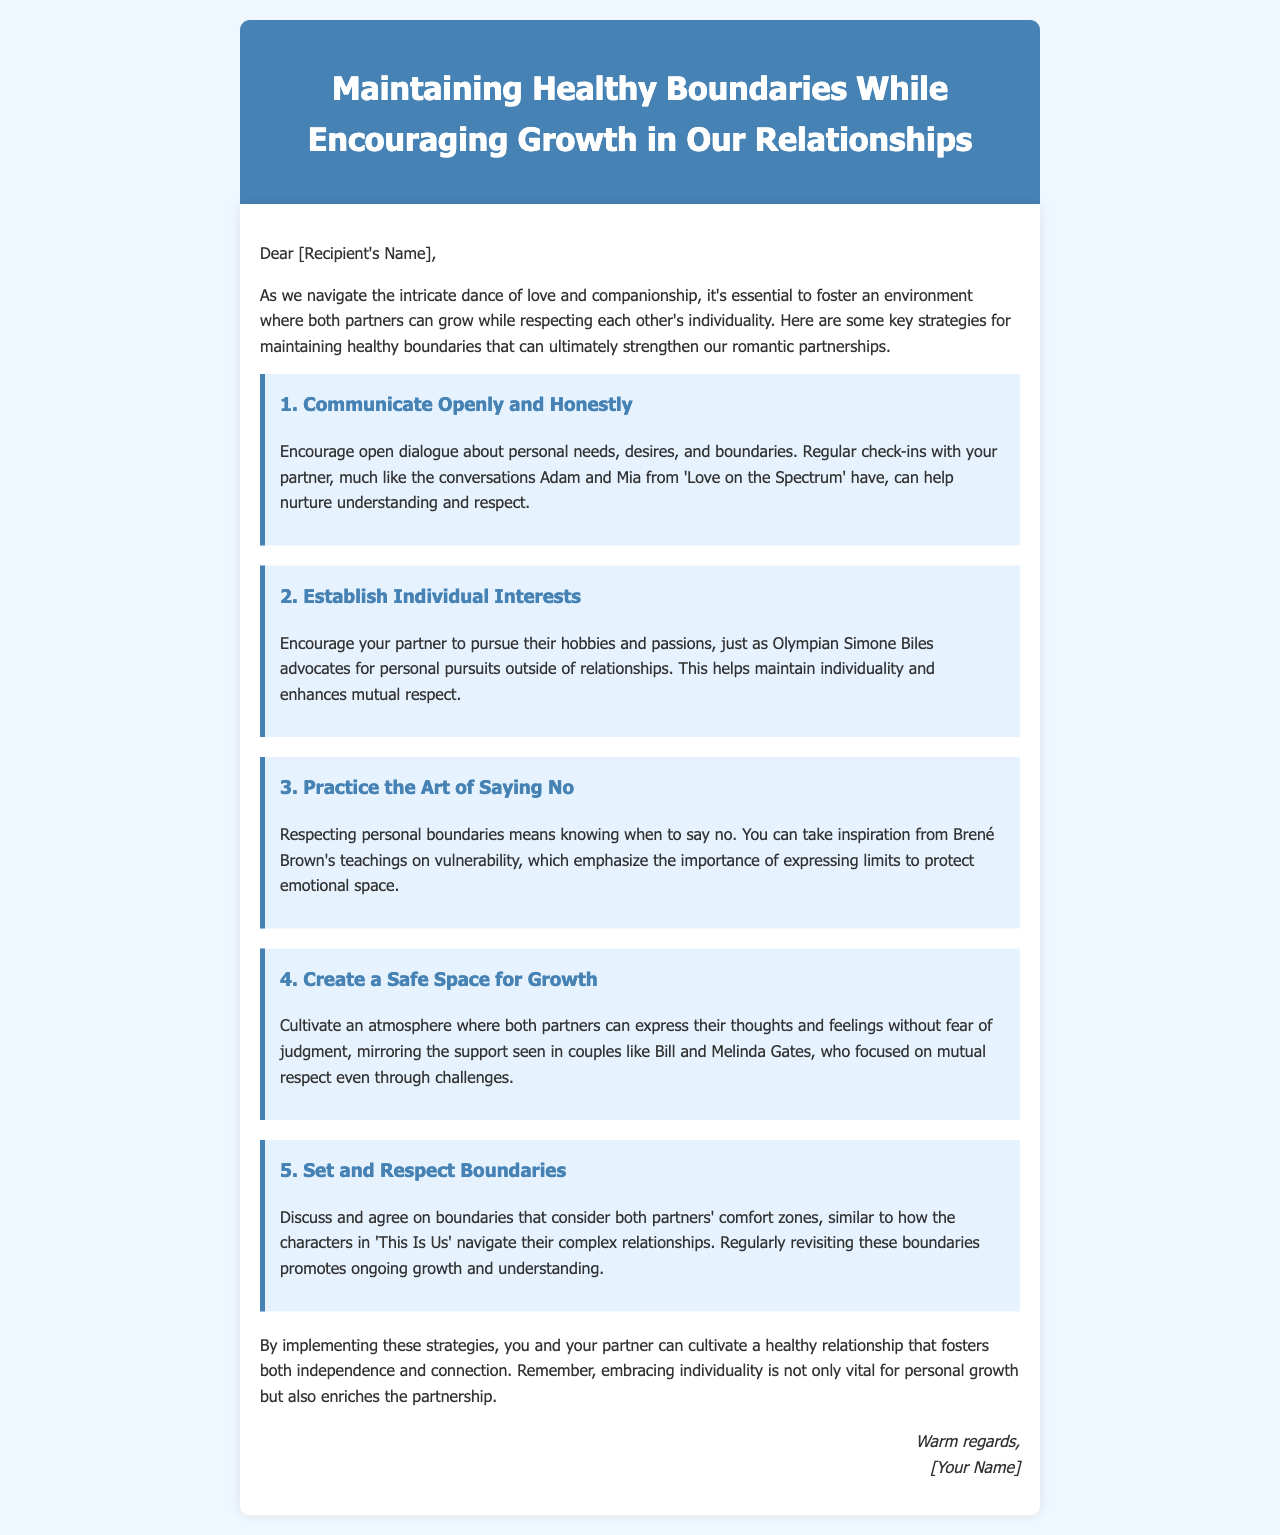What is the title of the document? The title is prominently featured in the header of the document and summarizes the content about relationships.
Answer: Maintaining Healthy Boundaries While Encouraging Growth in Our Relationships How many tips are provided in the document? The document lists five distinct strategies aimed at maintaining healthy boundaries.
Answer: 5 Who is mentioned as an advocate for personal pursuits outside of relationships? The document references a well-known figure who supports the idea of maintaining personal interests while in a relationship.
Answer: Simone Biles What is the first tip given for maintaining healthy boundaries? The content describes the initial recommendation for promoting healthy relationships and communication.
Answer: Communicate Openly and Honestly Which teaching style does the document refer to when discussing the importance of saying no? The document draws upon a specific author's teachings concerning emotional expression and boundaries.
Answer: Brené Brown's teachings What do the characters in 'This Is Us' demonstrate regarding boundaries? The document uses these fictional characters as an example to highlight a method for handling personal limits in relationships.
Answer: Navigate their complex relationships What is emphasized as vital for personal growth in the conclusion of the document? The conclusion reiterates the significance of maintaining individual identities alongside deepening connections.
Answer: Embracing individuality What is suggested as an outcome of implementing the strategies outlined? The document predicts a positive result that both partners may experience by following the proposed guidelines.
Answer: Cultivate a healthy relationship 